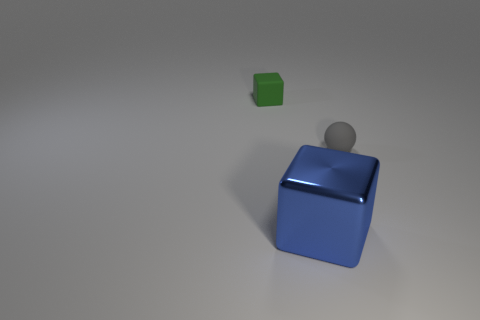Are there any other things that have the same size as the blue metallic cube?
Keep it short and to the point. No. What size is the matte thing in front of the green rubber thing?
Your answer should be very brief. Small. What is the shape of the other thing that is the same material as the tiny gray thing?
Keep it short and to the point. Cube. Does the ball have the same material as the cube on the left side of the shiny thing?
Your answer should be very brief. Yes. Does the rubber thing that is to the left of the blue block have the same shape as the big blue shiny object?
Provide a short and direct response. Yes. What is the material of the other object that is the same shape as the big metal object?
Keep it short and to the point. Rubber. There is a green object; is its shape the same as the tiny rubber object that is to the right of the blue block?
Your answer should be very brief. No. What color is the object that is on the right side of the small cube and behind the large shiny object?
Your answer should be compact. Gray. Is there a ball?
Give a very brief answer. Yes. Is the number of tiny matte cubes behind the small green block the same as the number of spheres?
Your response must be concise. No. 